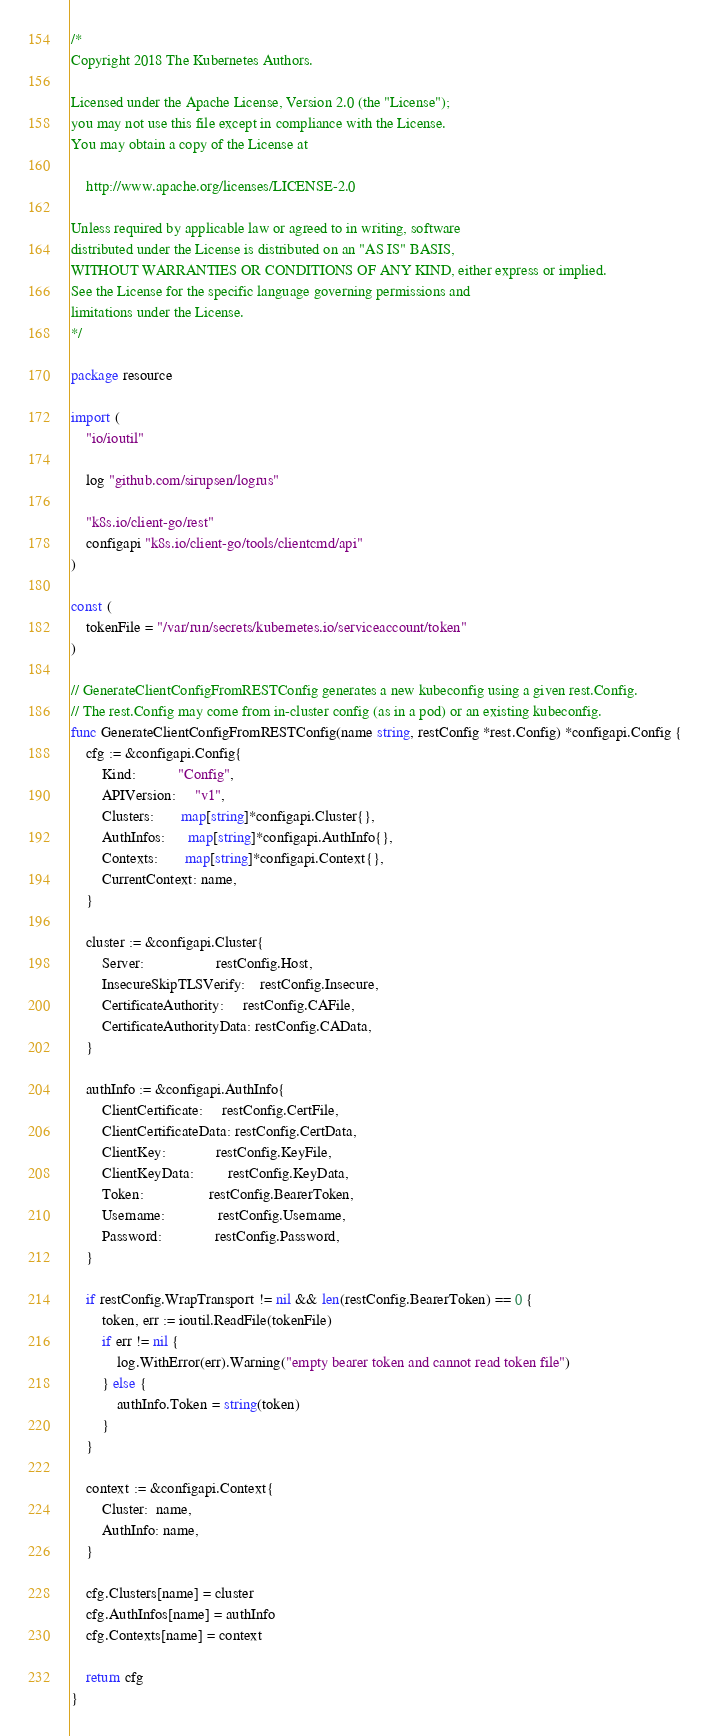Convert code to text. <code><loc_0><loc_0><loc_500><loc_500><_Go_>/*
Copyright 2018 The Kubernetes Authors.

Licensed under the Apache License, Version 2.0 (the "License");
you may not use this file except in compliance with the License.
You may obtain a copy of the License at

    http://www.apache.org/licenses/LICENSE-2.0

Unless required by applicable law or agreed to in writing, software
distributed under the License is distributed on an "AS IS" BASIS,
WITHOUT WARRANTIES OR CONDITIONS OF ANY KIND, either express or implied.
See the License for the specific language governing permissions and
limitations under the License.
*/

package resource

import (
	"io/ioutil"

	log "github.com/sirupsen/logrus"

	"k8s.io/client-go/rest"
	configapi "k8s.io/client-go/tools/clientcmd/api"
)

const (
	tokenFile = "/var/run/secrets/kubernetes.io/serviceaccount/token"
)

// GenerateClientConfigFromRESTConfig generates a new kubeconfig using a given rest.Config.
// The rest.Config may come from in-cluster config (as in a pod) or an existing kubeconfig.
func GenerateClientConfigFromRESTConfig(name string, restConfig *rest.Config) *configapi.Config {
	cfg := &configapi.Config{
		Kind:           "Config",
		APIVersion:     "v1",
		Clusters:       map[string]*configapi.Cluster{},
		AuthInfos:      map[string]*configapi.AuthInfo{},
		Contexts:       map[string]*configapi.Context{},
		CurrentContext: name,
	}

	cluster := &configapi.Cluster{
		Server:                   restConfig.Host,
		InsecureSkipTLSVerify:    restConfig.Insecure,
		CertificateAuthority:     restConfig.CAFile,
		CertificateAuthorityData: restConfig.CAData,
	}

	authInfo := &configapi.AuthInfo{
		ClientCertificate:     restConfig.CertFile,
		ClientCertificateData: restConfig.CertData,
		ClientKey:             restConfig.KeyFile,
		ClientKeyData:         restConfig.KeyData,
		Token:                 restConfig.BearerToken,
		Username:              restConfig.Username,
		Password:              restConfig.Password,
	}

	if restConfig.WrapTransport != nil && len(restConfig.BearerToken) == 0 {
		token, err := ioutil.ReadFile(tokenFile)
		if err != nil {
			log.WithError(err).Warning("empty bearer token and cannot read token file")
		} else {
			authInfo.Token = string(token)
		}
	}

	context := &configapi.Context{
		Cluster:  name,
		AuthInfo: name,
	}

	cfg.Clusters[name] = cluster
	cfg.AuthInfos[name] = authInfo
	cfg.Contexts[name] = context

	return cfg
}
</code> 